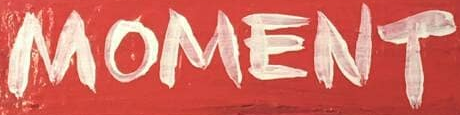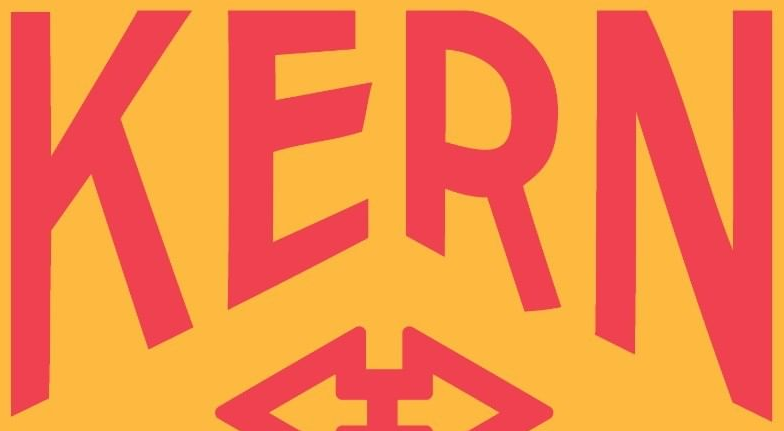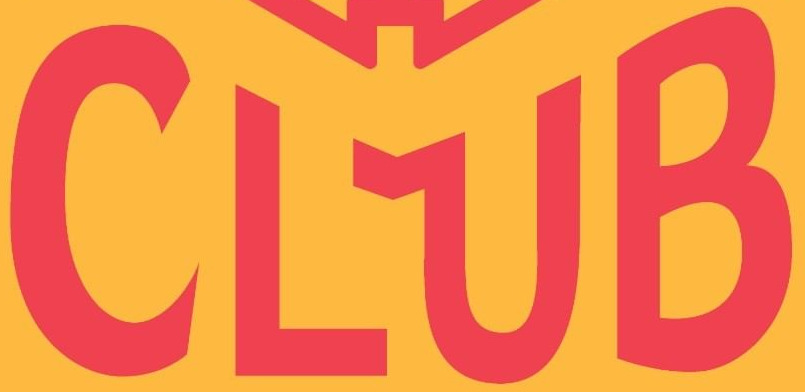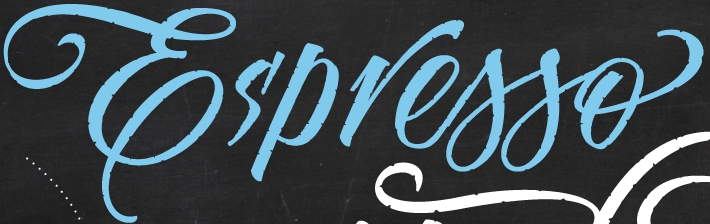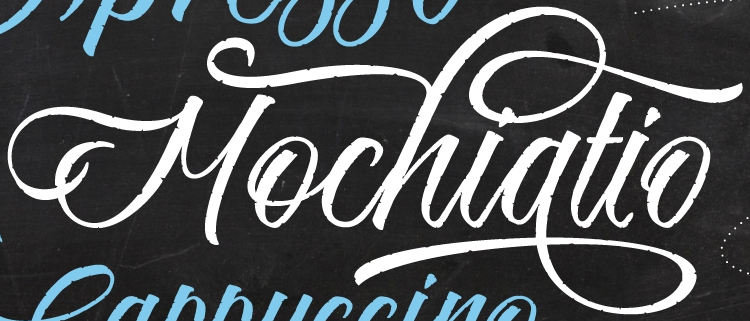Identify the words shown in these images in order, separated by a semicolon. MOMENT; KERN; CLUB; Es'presso; Mochiatio 